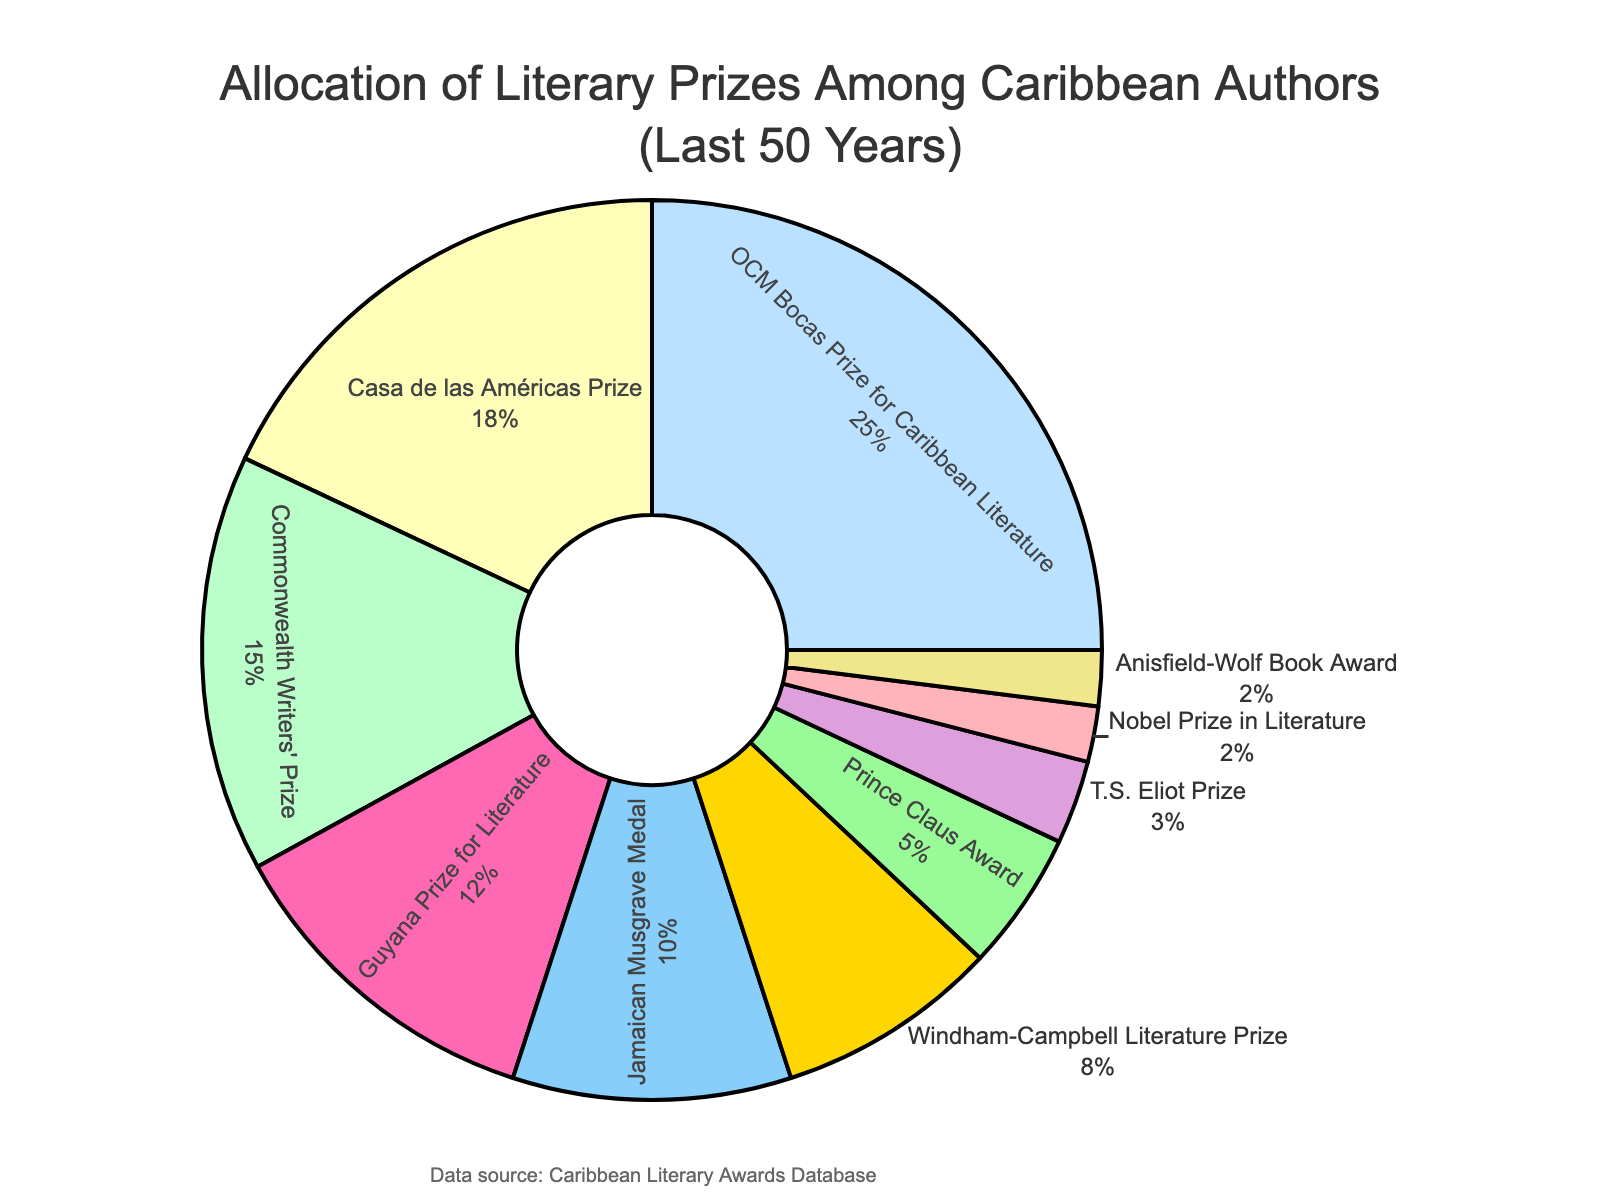What's the percentage of authors who won the OCM Bocas Prize for Caribbean Literature? The OCM Bocas Prize for Caribbean Literature is represented by a section of the pie that shows the percentage directly.
Answer: 25% Which prize has a lower allocation percentage: Nobel Prize in Literature or T.S. Eliot Prize? Compare the percentages shown for both the Nobel Prize in Literature and the T.S. Eliot Prize. The Nobel Prize in Literature has 2%, while the T.S. Eliot Prize has 3%.
Answer: Nobel Prize in Literature How much greater is the percentage for the Casa de las Américas Prize than the Anisfield-Wolf Book Award? Find the percentages for both prizes and subtract the smaller from the larger. Casa de las Américas Prize is 18%, and Anisfield-Wolf Book Award is 2%. So, 18% - 2% = 16%.
Answer: 16% What is the combined percentage of the Commonwealth Writers' Prize and the Jamaican Musgrave Medal? Add the percentages of the Commonwealth Writers' Prize (15%) and the Jamaican Musgrave Medal (10%). So, 15% + 10% = 25%.
Answer: 25% Which two prizes have the same percentage of allocation? Compare percentages for all the prizes to identify any that are the same. Both the Nobel Prize in Literature and Anisfield-Wolf Book Award have 2%.
Answer: Nobel Prize in Literature and Anisfield-Wolf Book Award What's the difference in percentage allocation between the Guyana Prize for Literature and the Windham-Campbell Literature Prize? Guyana Prize for Literature has 12% and Windham-Campbell Literature Prize has 8%. Subtract the smaller from the larger: 12% - 8% = 4%.
Answer: 4% Which prize allocation is closest to that of the Prince Claus Award? Look at the percentages close to that of the Prince Claus Award (5%). The T.S. Eliot Prize at 3% is closest.
Answer: T.S. Eliot Prize 